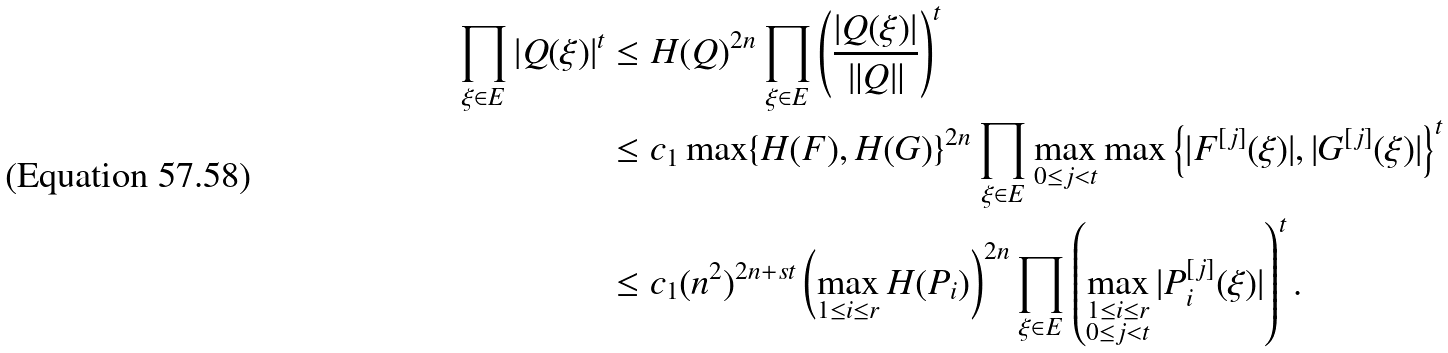Convert formula to latex. <formula><loc_0><loc_0><loc_500><loc_500>\prod _ { \xi \in E } | Q ( \xi ) | ^ { t } & \leq H ( Q ) ^ { 2 n } \prod _ { \xi \in E } \left ( \frac { | Q ( \xi ) | } { \| Q \| } \right ) ^ { t } \\ & \leq c _ { 1 } \max \{ H ( F ) , H ( G ) \} ^ { 2 n } \prod _ { \xi \in E } \max _ { 0 \leq j < t } \max \left \{ | F ^ { [ j ] } ( \xi ) | , | G ^ { [ j ] } ( \xi ) | \right \} ^ { t } \\ & \leq c _ { 1 } ( n ^ { 2 } ) ^ { 2 n + s t } \left ( \max _ { 1 \leq i \leq r } H ( P _ { i } ) \right ) ^ { 2 n } \prod _ { \xi \in E } \left ( \max _ { \substack { 1 \leq i \leq r \\ 0 \leq j < t } } | P _ { i } ^ { [ j ] } ( \xi ) | \right ) ^ { t } .</formula> 